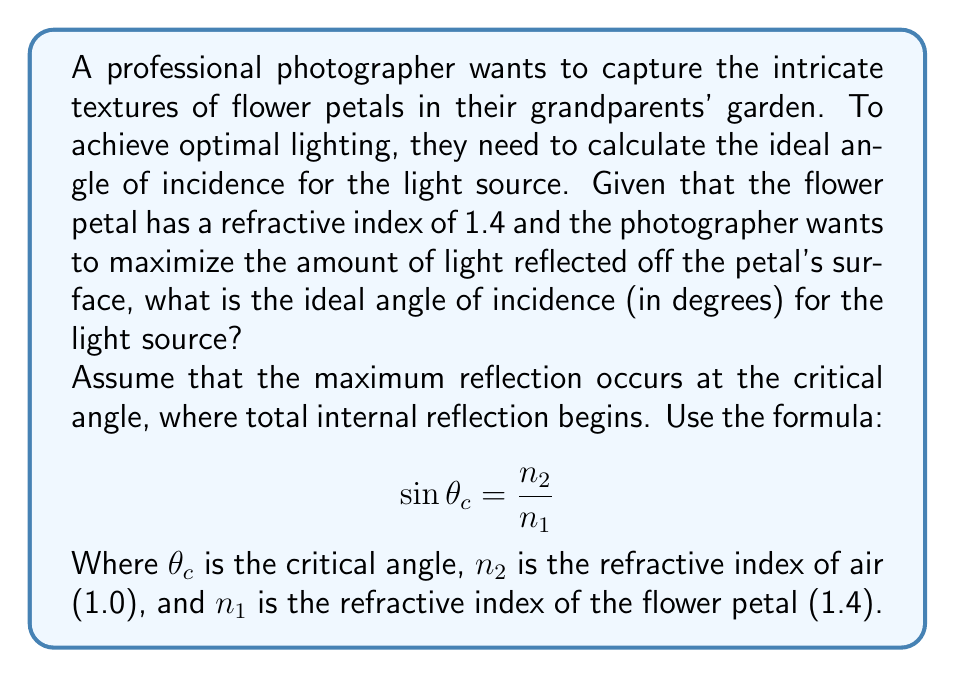Show me your answer to this math problem. To solve this problem, we'll follow these steps:

1) We're given that the refractive index of the flower petal ($n_1$) is 1.4, and we know that the refractive index of air ($n_2$) is approximately 1.0.

2) We'll use the formula for the critical angle:

   $$\sin \theta_c = \frac{n_2}{n_1}$$

3) Substituting our values:

   $$\sin \theta_c = \frac{1.0}{1.4}$$

4) To solve for $\theta_c$, we need to take the inverse sine (arcsin) of both sides:

   $$\theta_c = \arcsin(\frac{1.0}{1.4})$$

5) Using a calculator or computer, we can evaluate this:

   $$\theta_c \approx 0.7553 \text{ radians}$$

6) To convert this to degrees, we multiply by $\frac{180}{\pi}$:

   $$\theta_c \approx 0.7553 \times \frac{180}{\pi} \approx 43.23°$$

7) However, this is the critical angle inside the petal. The photographer needs the angle of incidence from outside the petal. This is complementary to the critical angle:

   $$\text{Ideal angle of incidence} = 90° - 43.23° = 46.77°$$

Therefore, the ideal angle of incidence for the light source is approximately 46.77°.
Answer: 46.77° 